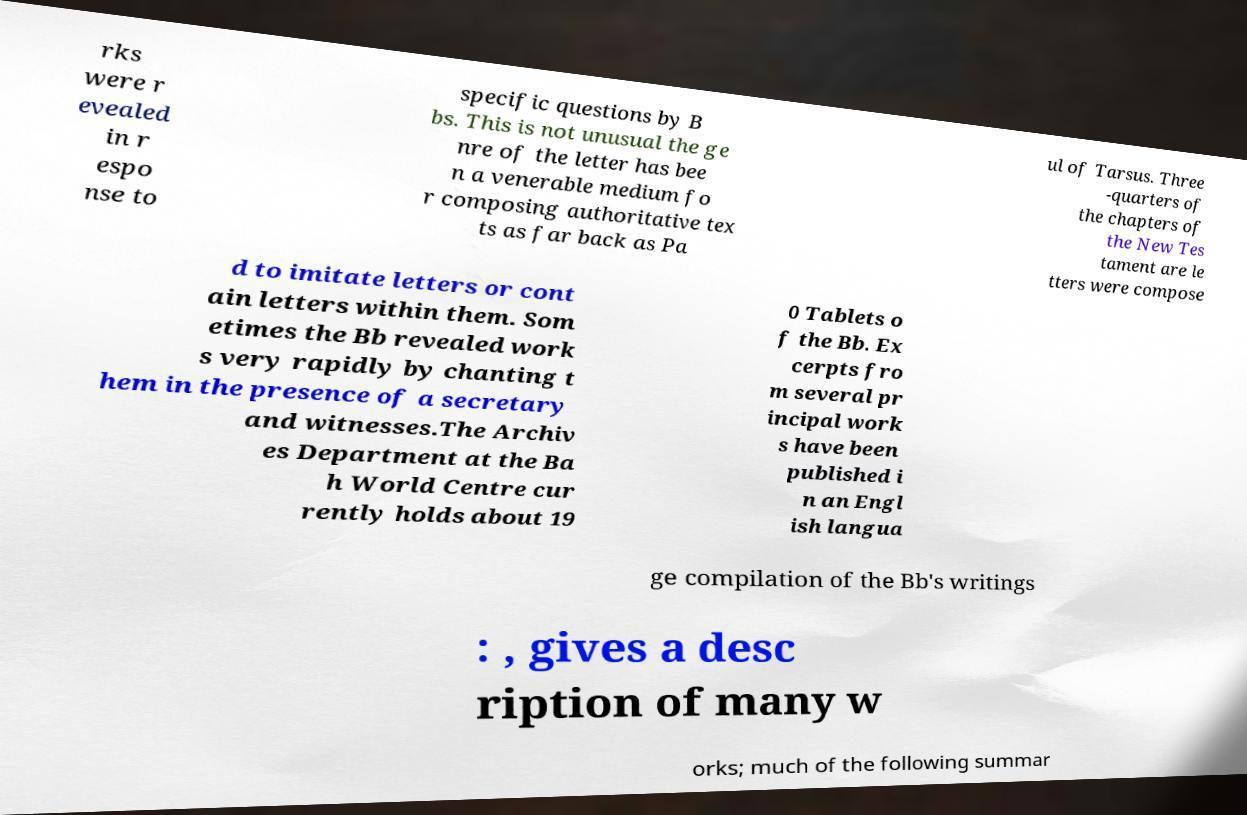What messages or text are displayed in this image? I need them in a readable, typed format. rks were r evealed in r espo nse to specific questions by B bs. This is not unusual the ge nre of the letter has bee n a venerable medium fo r composing authoritative tex ts as far back as Pa ul of Tarsus. Three -quarters of the chapters of the New Tes tament are le tters were compose d to imitate letters or cont ain letters within them. Som etimes the Bb revealed work s very rapidly by chanting t hem in the presence of a secretary and witnesses.The Archiv es Department at the Ba h World Centre cur rently holds about 19 0 Tablets o f the Bb. Ex cerpts fro m several pr incipal work s have been published i n an Engl ish langua ge compilation of the Bb's writings : , gives a desc ription of many w orks; much of the following summar 